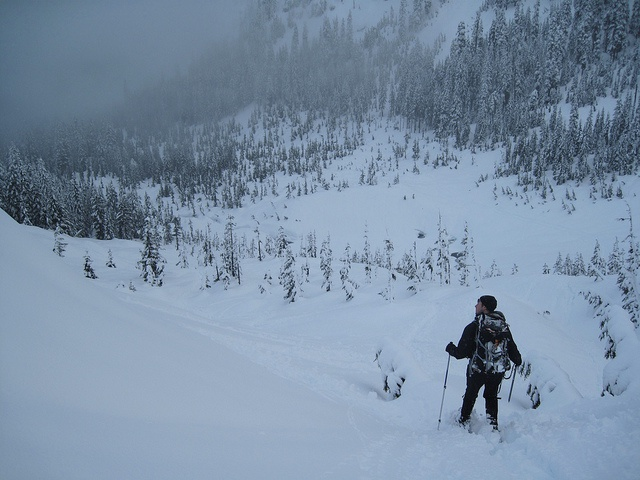Describe the objects in this image and their specific colors. I can see people in gray, black, and darkblue tones, backpack in gray, black, and darkblue tones, and skis in gray and darkgray tones in this image. 